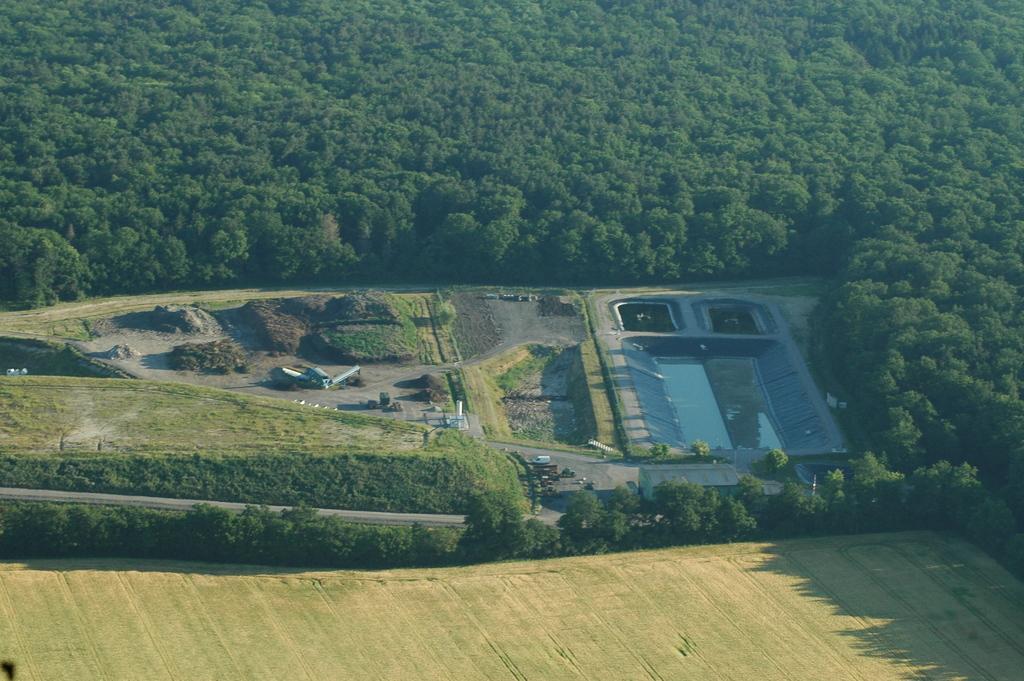In one or two sentences, can you explain what this image depicts? As we can see in the image there are trees and vehicles. There is grass and water. 